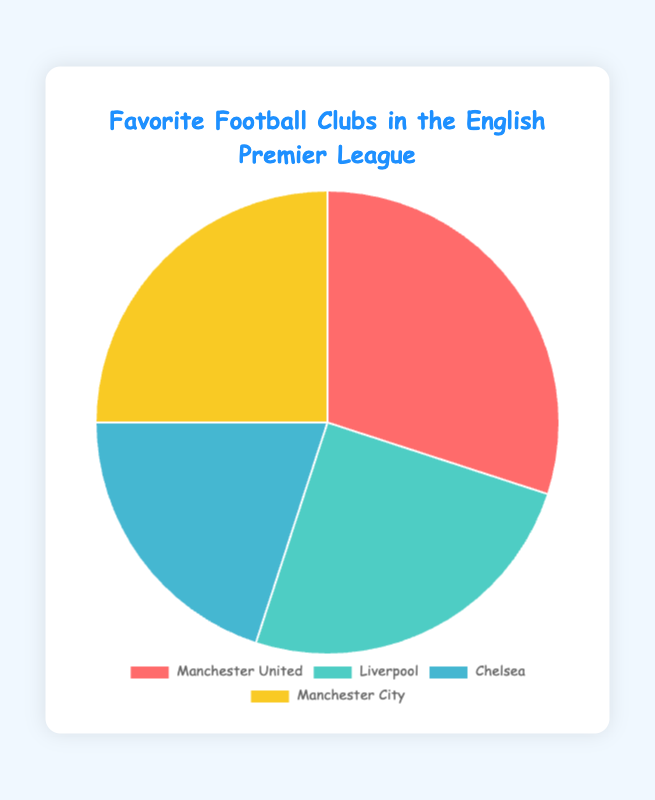What's the most popular football club in the pie chart? Manchester United has the highest percentage at 30%. Therefore, it is the most popular football club among the four.
Answer: Manchester United Which two clubs share the same percentage of popularity? By observing the pie chart, both Liverpool and Manchester City have a percentage of 25%. Therefore, they share the same popularity.
Answer: Liverpool and Manchester City What is the combined percentage of Liverpool and Manchester City? Liverpool has a percentage of 25%, and Manchester City also has 25%. Adding them together gives 25% + 25% = 50%.
Answer: 50% How much more popular is Manchester United compared to Chelsea? Manchester United has 30% popularity, while Chelsea has 20%. The difference is 30% - 20% = 10%.
Answer: 10% If the total number of votes is 1,000, how many votes did each club receive? Manchester United: 30% of 1,000 is 0.3 * 1,000 = 300. Liverpool: 25% of 1,000 is 0.25 * 1,000 = 250. Chelsea: 20% of 1,000 is 0.2 * 1,000 = 200. Manchester City: 25% of 1,000 is 0.25 * 1,000 = 250.
Answer: Manchester United: 300, Liverpool: 250, Chelsea: 200, Manchester City: 250 Which club's color is represented by blue in the pie chart? Chelsea is represented by the color blue in the pie chart.
Answer: Chelsea Which combination of clubs has an equal percentage to Manchester United's popularity? Liverpool (25%) and Chelsea (20%) combined equal Manchester United’s popularity (30%).
Answer: Liverpool and Chelsea If Chelsea's popularity increased by 10%, what would the new percentage be? Chelsea's current percentage is 20%. An increase of 10% would result in 20% + 10% = 30%.
Answer: 30% What is the average popularity percentage of all four clubs? Sum up the percentages: 30% (Manchester United) + 25% (Liverpool) + 20% (Chelsea) + 25% (Manchester City). Total is 100%. Divide by 4: 100% / 4 = 25%.
Answer: 25% If Liverpool’s popularity doubled, what would be the new total percentage on the pie chart? Doubling Liverpool's 25% gives 50%. Adding this to the remaining percentages: 30% (Manchester United) + 20% (Chelsea) + 25% (Manchester City) = 75%. The new total would be 50% + 75% = 125%.
Answer: 125% 